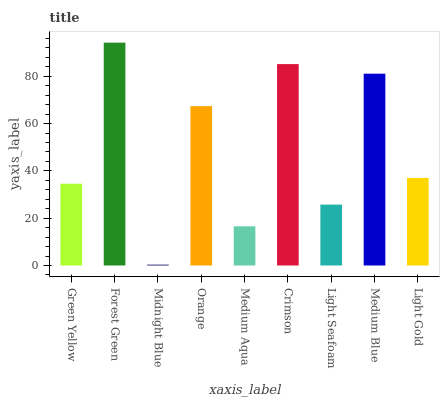Is Midnight Blue the minimum?
Answer yes or no. Yes. Is Forest Green the maximum?
Answer yes or no. Yes. Is Forest Green the minimum?
Answer yes or no. No. Is Midnight Blue the maximum?
Answer yes or no. No. Is Forest Green greater than Midnight Blue?
Answer yes or no. Yes. Is Midnight Blue less than Forest Green?
Answer yes or no. Yes. Is Midnight Blue greater than Forest Green?
Answer yes or no. No. Is Forest Green less than Midnight Blue?
Answer yes or no. No. Is Light Gold the high median?
Answer yes or no. Yes. Is Light Gold the low median?
Answer yes or no. Yes. Is Green Yellow the high median?
Answer yes or no. No. Is Midnight Blue the low median?
Answer yes or no. No. 